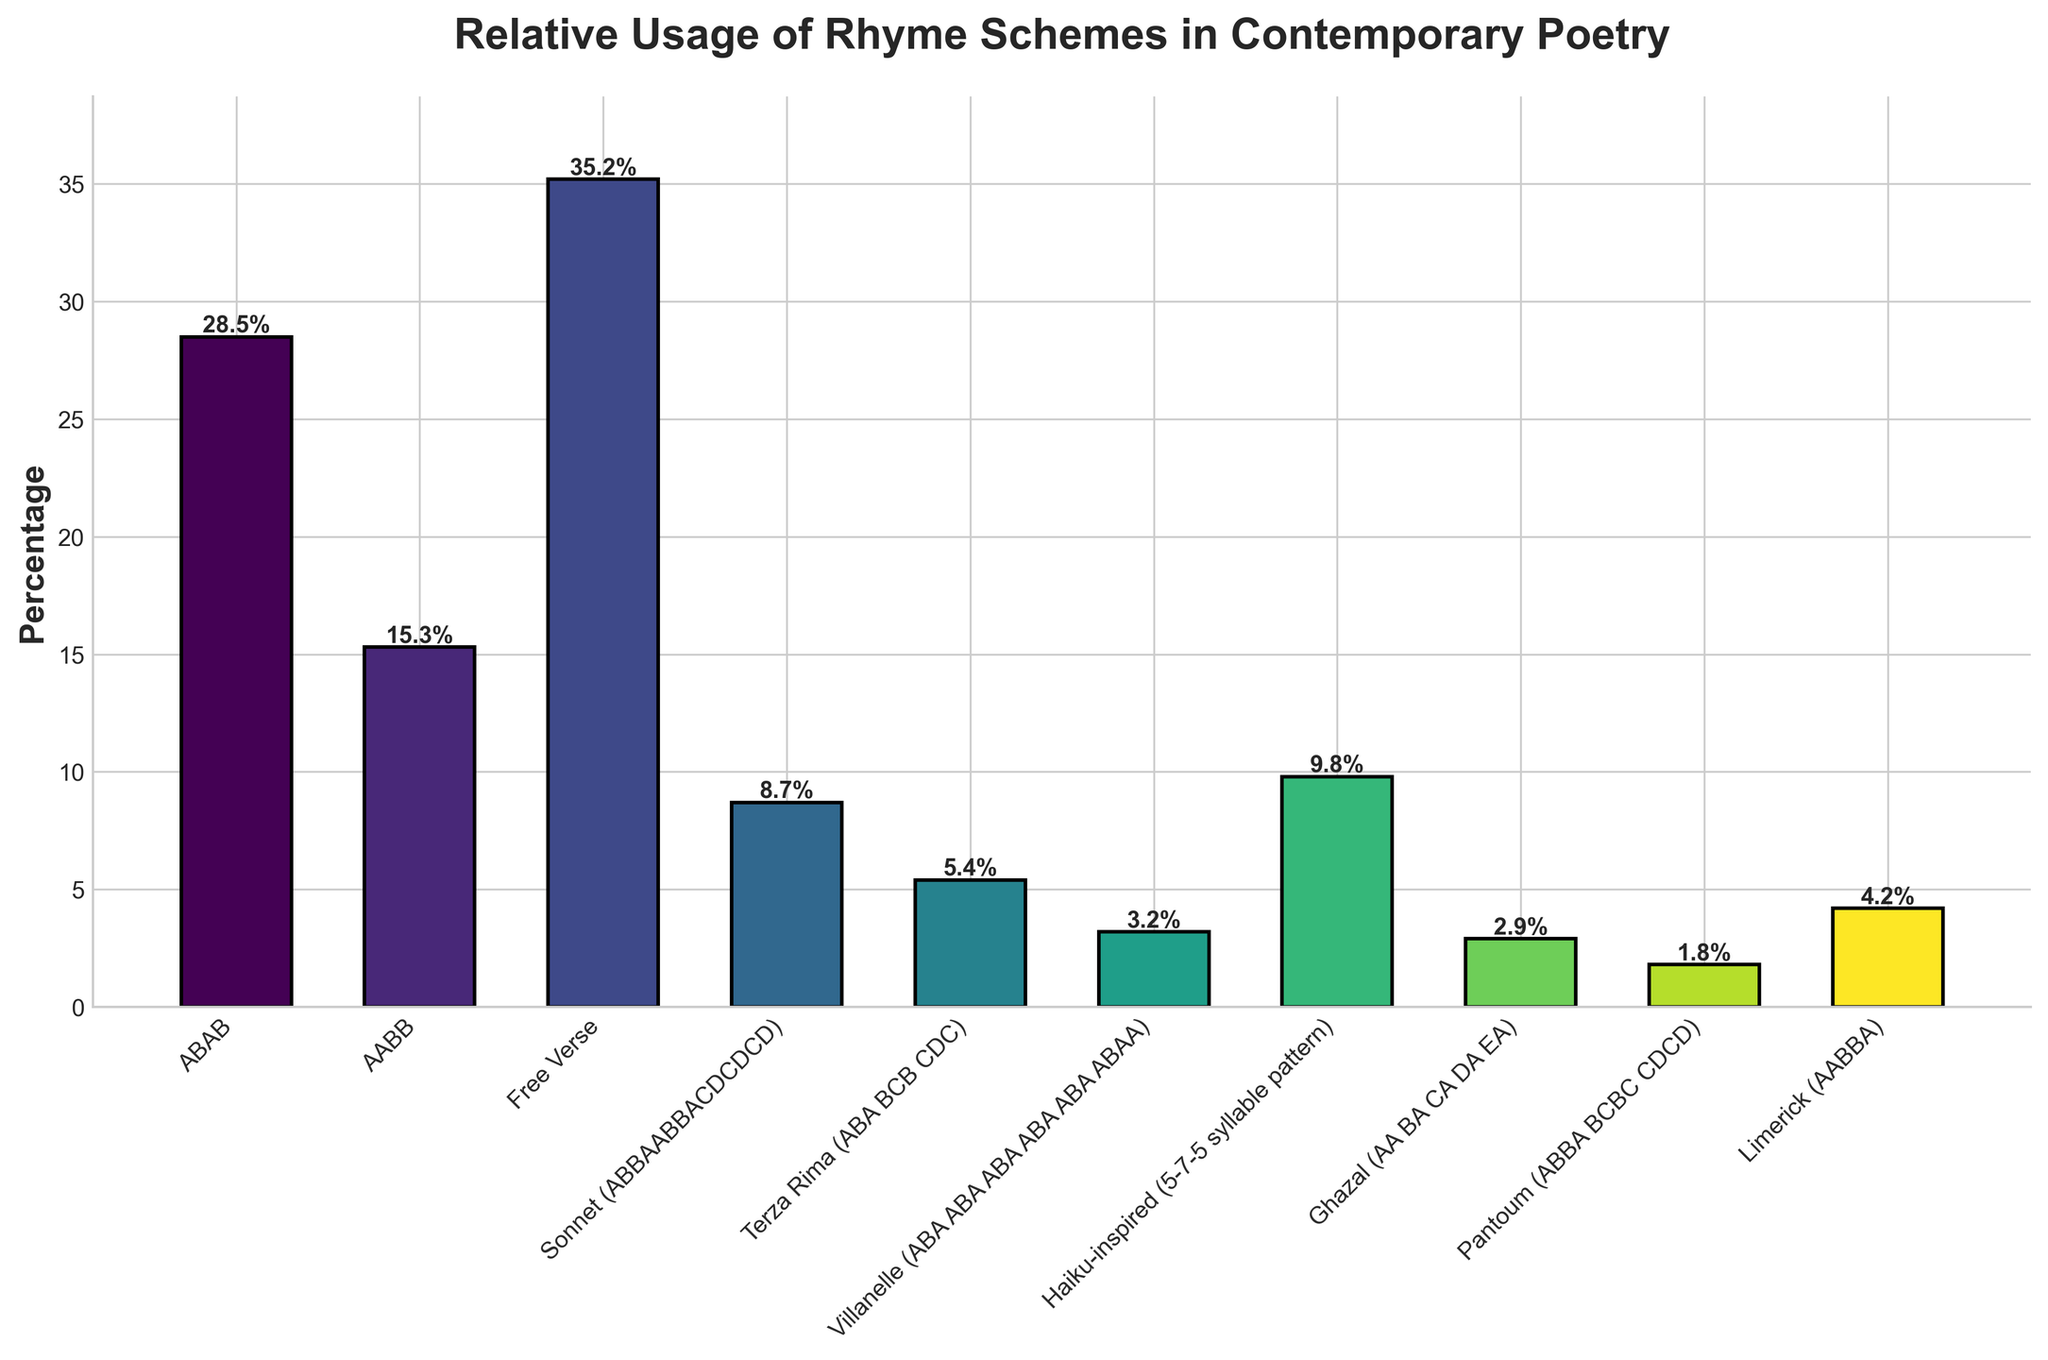What rhyme scheme has the highest percentage of use? Identify the bar with the highest height. The bar labeled "Free Verse" reaches the highest point on the vertical axis, indicating its percentage value is the highest among all schemes.
Answer: Free Verse Which two rhyme schemes have the most similar usage percentages? Compare the heights of the bars visually. ABAB and Haiku-inspired bars appear to be closer in height to each other than to the other bars. Their percentages are 28.5% and 9.8%, respectively.
Answer: Haiku-inspired and Sonnet What is the total percentage of usage for the ABAB and AABB rhyme schemes combined? Add the percentages of ABAB (28.5%) and AABB (15.3%). The sum of their percentages is calculated as 28.5% + 15.3% = 43.8%.
Answer: 43.8% What is the difference in percentage between the most and least used rhyme schemes? Identify the highest and lowest bars on the chart. Free Verse has the highest percentage at 35.2%, and Pantoum has the lowest at 1.8%. Subtract the lowest from the highest: 35.2% - 1.8% = 33.4%.
Answer: 33.4% Which rhyme scheme is used less, Haiku-inspired or Villanelle? Compare the heights of the bars labeled "Haiku-inspired" and "Villanelle." The Haiku-inspired bar is higher than the Villanelle bar, indicating Haiku-inspired is used more.
Answer: Villanelle If you combine the usage percentages of Terza Rima, Villanelle, and Limerick, what is the total? Add the percentages of Terza Rima (5.4%), Villanelle (3.2%), and Limerick (4.2%). The total is 5.4% + 3.2% + 4.2% = 12.8%.
Answer: 12.8% What percentage of usage does Sonnet have over Terza Rima? Compare the bars labeled "Sonnet" and "Terza Rima". The Sonnet bar has a percentage of 8.7% and Terza Rima 5.4%. Subtract Terza Rima's percentage from Sonnet's: 8.7% - 5.4% = 3.3%.
Answer: 3.3% Which color represents the Ghazal rhyme scheme? Identify the bar with the label "Ghazal" and observe its color, which is the third bar from the right. The color is distinguishable visually as a unique shade in the palette used.
Answer: Green (though answer may vary based on actual visual) Among the rhyme schemes with percentages below 10%, which one has the highest usage? List the percentages below 10% and compare: Sonnet (8.7%), Terza Rima (5.4%), Villanelle (3.2%), Ghazal (2.9%), Pantoum (1.8%), Limerick (4.2%). The highest is Haiku-inspired with 9.8%.
Answer: Haiku-inspired 